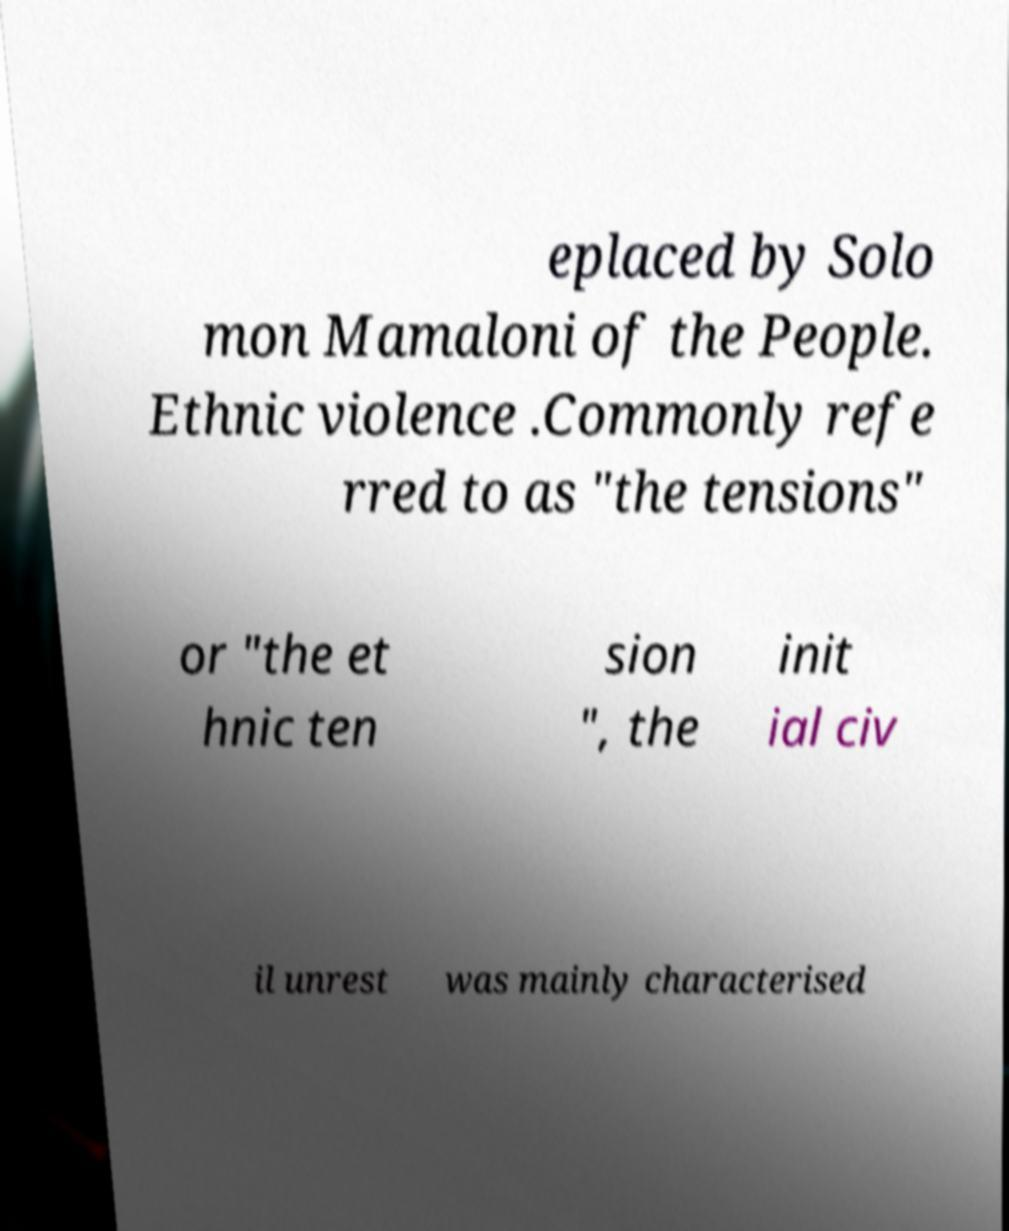Please identify and transcribe the text found in this image. eplaced by Solo mon Mamaloni of the People. Ethnic violence .Commonly refe rred to as "the tensions" or "the et hnic ten sion ", the init ial civ il unrest was mainly characterised 